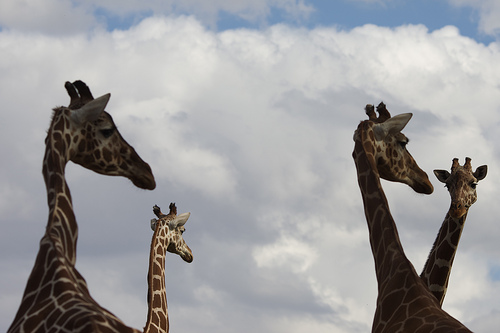<image>What type of vegetation is in the background? There is no vegetation in the background of the image. What type of vegetation is in the background? There is no vegetation in the background. 